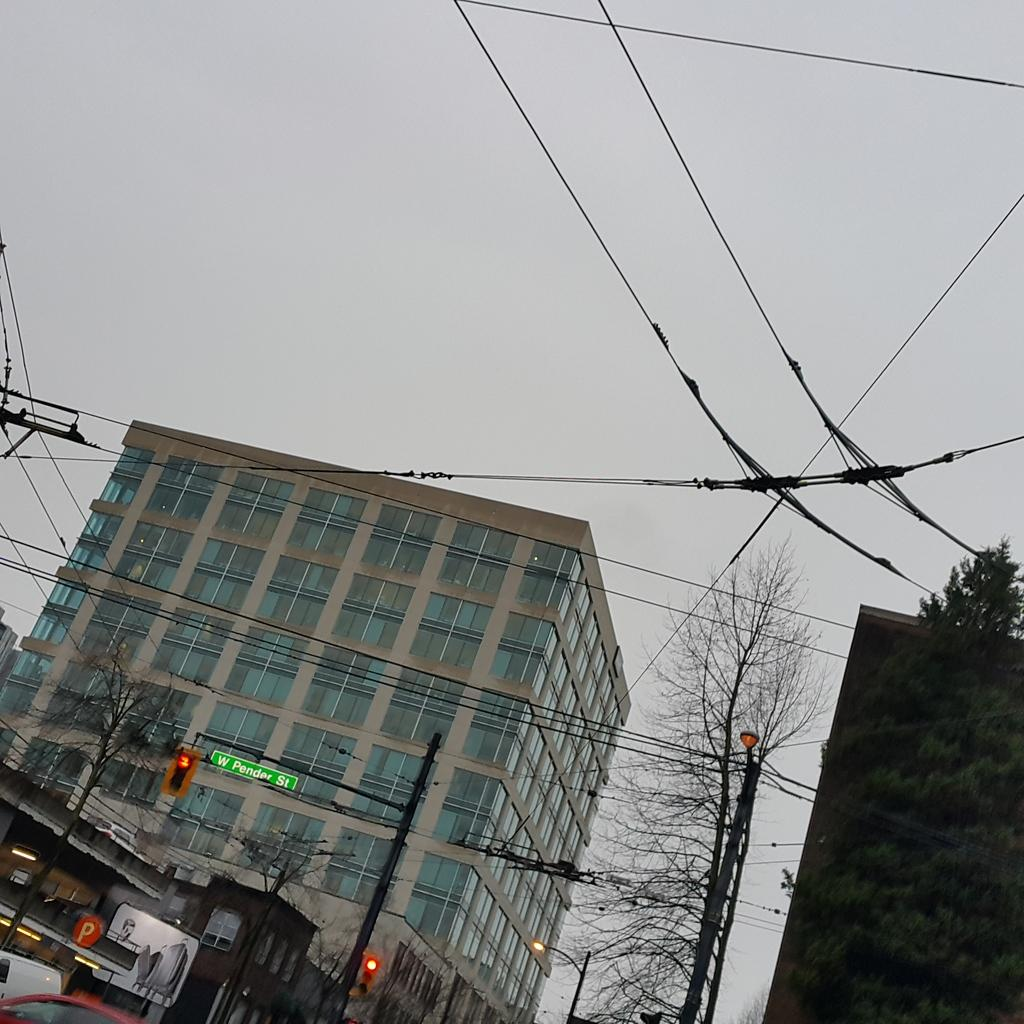What type of natural elements can be seen in the image? There are trees in the image. What type of man-made structures are present in the image? There are traffic signals, a pole, and buildings in the image. What type of transportation is visible in the image? There are vehicles on a path in the image. Can you describe the engine of the bear in the image? There are no bears present in the image, and therefore no engine can be described. What type of experience can be gained from observing the image? The image itself does not provide an experience, but it may evoke feelings or thoughts in the observer. 